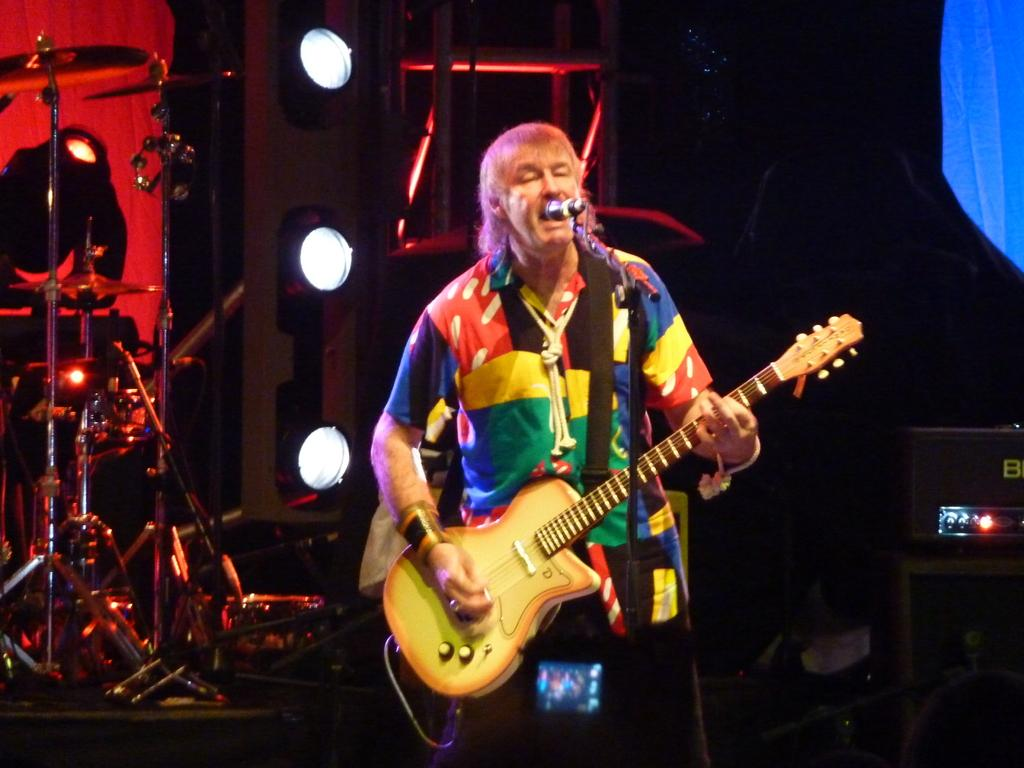What is the man in the image doing? The man is standing, playing a guitar, and singing into a microphone. What instrument can be seen in the image besides the guitar? There are drums in the background of the image. What additional equipment is present in the background of the image? There are focus lights and speakers in the background of the image. What type of key is the man using to play the guitar in the image? The image does not show the man using a key to play the guitar; he is using his hands to strum the strings. 